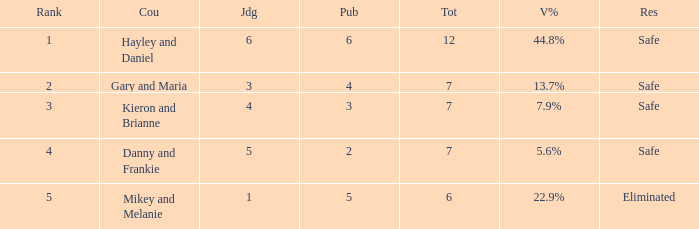What was the result for the total of 12? Safe. 